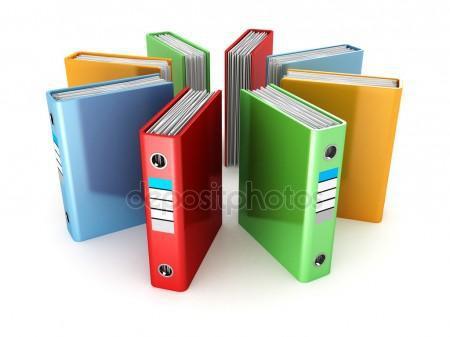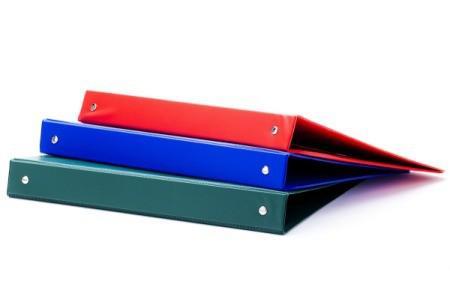The first image is the image on the left, the second image is the image on the right. Assess this claim about the two images: "There is a stack of three binders in the image on the right.". Correct or not? Answer yes or no. Yes. The first image is the image on the left, the second image is the image on the right. For the images shown, is this caption "One image shows multiple different colored binders without any labels on their ends, and the other image shows different colored binders with end labels." true? Answer yes or no. Yes. 